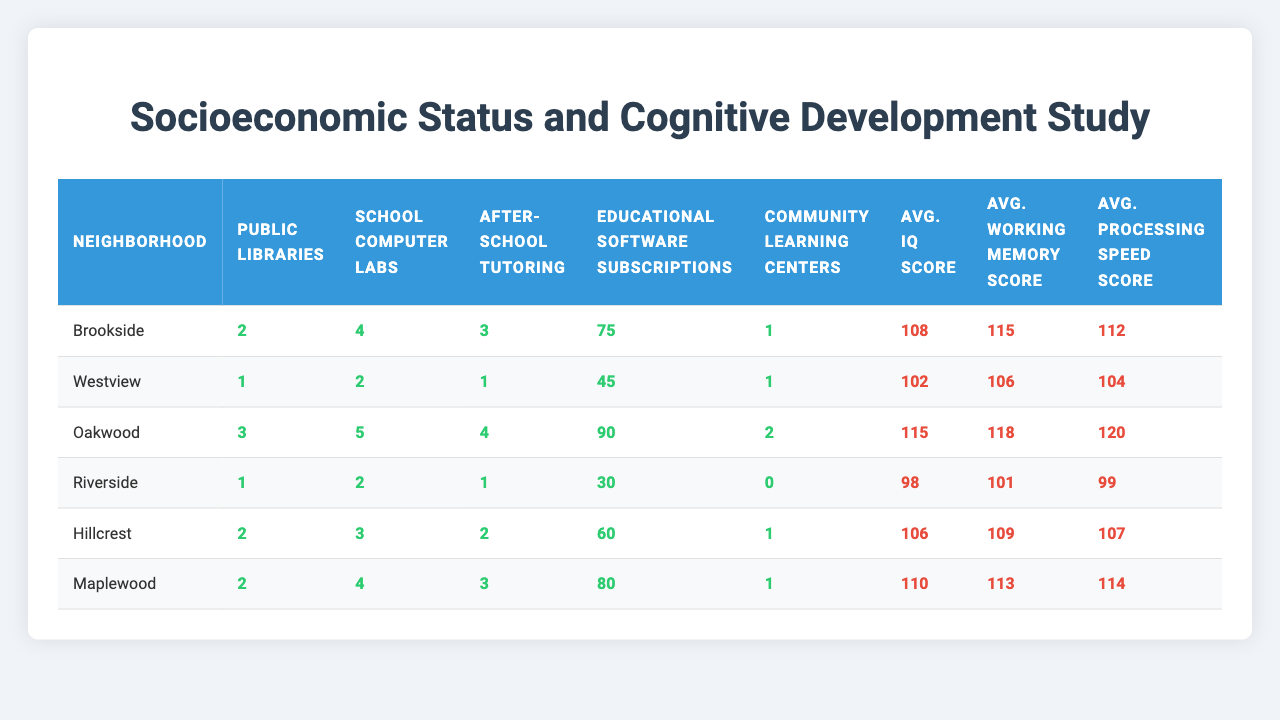What is the average IQ score of students in Oakwood? The table shows that the average IQ score for Oakwood is listed directly in the cognitive performance scores section. According to the data, it is 115.
Answer: 115 How many public libraries are there in Riverside? The table lists the number of public libraries directly under the resource availability section for Riverside, which shows there is 1 public library.
Answer: 1 Which neighborhood has the highest average working memory score? By comparing the average working memory scores in the table, Oakwood has the highest score at 118.
Answer: Oakwood What is the total number of community learning centers in Brookside and Hillcrest combined? The table indicates that Brookside has 1 community learning center and Hillcrest has 1 as well. Adding these together gives 1 + 1 = 2.
Answer: 2 Is it true that Westview has more after-school tutoring programs than Riverside? The table shows that Westview has 1 after-school tutoring program, while Riverside also has 1. Therefore, the statement is false.
Answer: No What is the average processing speed score in Maplewood compared to Westview? The average processing speed score in Maplewood is 114 and in Westview, it is 104. Comparing the two shows Maplewood has a higher score by 10 points.
Answer: Maplewood is 10 points higher How does the number of school computer labs in Oakwood compare to that in Hillcrest? The table indicates that Oakwood has 5 school computer labs while Hillcrest has 3. Oakwood has 2 more computer labs than Hillcrest.
Answer: Oakwood has 2 more What is the average of the average IQ scores for all neighborhoods? The average IQ scores are: 108 (Brookside), 102 (Westview), 115 (Oakwood), 98 (Riverside), 106 (Hillcrest), and 110 (Maplewood). Adding these gives 639, and dividing by 6 neighborhoods, we get 106.5.
Answer: 106.5 Which neighborhood has the lowest score across all cognitive performance measurements? By examining the average scores, Riverside has the lowest averages: 98 (IQ), 101 (working memory), and 99 (processing speed).
Answer: Riverside What is the difference in the number of educational software subscriptions between Maplewood and Riverside? Maplewood has 80 educational software subscriptions while Riverside has 30. The difference is 80 - 30 = 50.
Answer: 50 